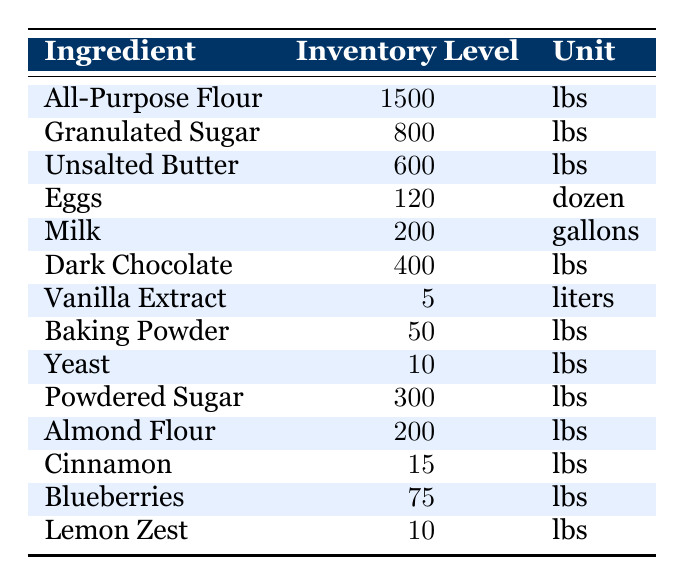What is the inventory level of All-Purpose Flour? The table lists the inventory level of All-Purpose Flour as 1500 lbs.
Answer: 1500 lbs How many pounds of Granulated Sugar are available? The table indicates that there are 800 lbs of Granulated Sugar.
Answer: 800 lbs What is the unit of measurement for Eggs? The table shows that Eggs are measured in dozen.
Answer: dozen Which ingredient has the lowest inventory level? By examining the inventory levels, Yeast has the lowest inventory level at 10 lbs.
Answer: Yeast How much more inventory does All-Purpose Flour have compared to Unsalted Butter? All-Purpose Flour has 1500 lbs and Unsalted Butter has 600 lbs. The difference is calculated as 1500 - 600 = 900 lbs.
Answer: 900 lbs What is the total inventory level of all ingredients listed? Adding all inventory levels together: 1500 + 800 + 600 + 120 + 200 + 400 + 5 + 50 + 10 + 300 + 200 + 15 + 75 + 10 = 3195.
Answer: 3195 lbs Is the inventory level of Vanilla Extract greater than that of Baking Powder? The table shows Vanilla Extract has 5 liters and Baking Powder has 50 lbs. Since they are in different units, a direct comparison isn't possible, but 50 lbs is significantly greater than 5 liters.
Answer: No What are the total pounds of Sugar (Granulated Sugar and Powdered Sugar)? Granulated Sugar has 800 lbs and Powdered Sugar has 300 lbs. Adding these together gives 800 + 300 = 1100 lbs.
Answer: 1100 lbs What percentage of the total inventory does Milk represent? Total inventory is 3195 lbs, and Milk is 200 gallons, which is treated as 200 lbs for the calculation. The percentage is (200 / 3195) * 100 ≈ 6.26%.
Answer: 6.26% If we wanted to make a pastry that requires all of the listed ingredients, which ingredient would run out first based on the inventory levels? By evaluating the inventory levels, the ingredient with the lowest amount is Yeast at 10 lbs, suggesting that it would run out first if all ingredients were used equally.
Answer: Yeast 